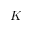<formula> <loc_0><loc_0><loc_500><loc_500>K</formula> 